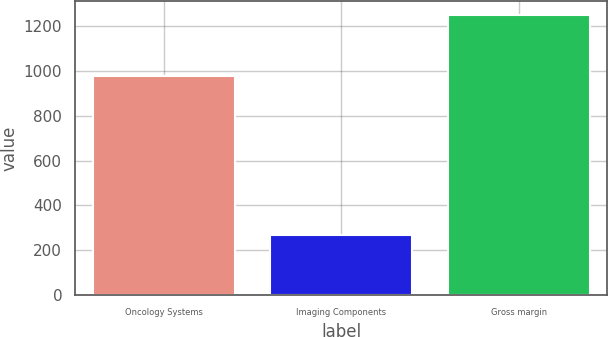Convert chart. <chart><loc_0><loc_0><loc_500><loc_500><bar_chart><fcel>Oncology Systems<fcel>Imaging Components<fcel>Gross margin<nl><fcel>976.2<fcel>268.1<fcel>1249.7<nl></chart> 